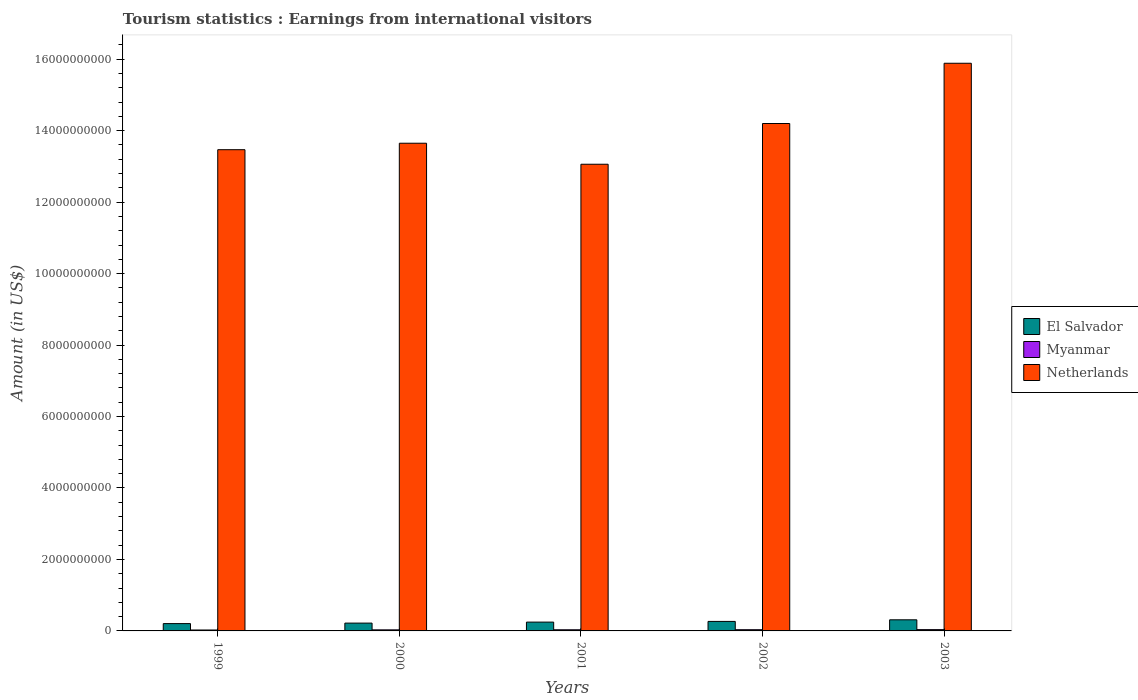How many different coloured bars are there?
Ensure brevity in your answer.  3. Are the number of bars on each tick of the X-axis equal?
Provide a short and direct response. Yes. In how many cases, is the number of bars for a given year not equal to the number of legend labels?
Offer a very short reply. 0. What is the earnings from international visitors in Myanmar in 2001?
Your answer should be very brief. 3.20e+07. Across all years, what is the maximum earnings from international visitors in El Salvador?
Make the answer very short. 3.11e+08. Across all years, what is the minimum earnings from international visitors in Myanmar?
Give a very brief answer. 2.60e+07. In which year was the earnings from international visitors in Myanmar maximum?
Your answer should be very brief. 2003. What is the total earnings from international visitors in Netherlands in the graph?
Keep it short and to the point. 7.03e+1. What is the difference between the earnings from international visitors in Netherlands in 1999 and that in 2002?
Ensure brevity in your answer.  -7.33e+08. What is the difference between the earnings from international visitors in Netherlands in 2000 and the earnings from international visitors in Myanmar in 1999?
Make the answer very short. 1.36e+1. What is the average earnings from international visitors in Myanmar per year?
Offer a very short reply. 3.16e+07. In the year 2000, what is the difference between the earnings from international visitors in Netherlands and earnings from international visitors in Myanmar?
Offer a terse response. 1.36e+1. In how many years, is the earnings from international visitors in Myanmar greater than 12400000000 US$?
Offer a terse response. 0. What is the ratio of the earnings from international visitors in Myanmar in 1999 to that in 2003?
Ensure brevity in your answer.  0.72. Is the difference between the earnings from international visitors in Netherlands in 2001 and 2002 greater than the difference between the earnings from international visitors in Myanmar in 2001 and 2002?
Give a very brief answer. No. What is the difference between the highest and the lowest earnings from international visitors in Myanmar?
Your answer should be compact. 1.00e+07. In how many years, is the earnings from international visitors in El Salvador greater than the average earnings from international visitors in El Salvador taken over all years?
Provide a succinct answer. 2. Is the sum of the earnings from international visitors in Netherlands in 1999 and 2000 greater than the maximum earnings from international visitors in Myanmar across all years?
Offer a terse response. Yes. What does the 1st bar from the left in 2002 represents?
Your answer should be very brief. El Salvador. What does the 2nd bar from the right in 2002 represents?
Your response must be concise. Myanmar. What is the difference between two consecutive major ticks on the Y-axis?
Provide a short and direct response. 2.00e+09. Does the graph contain any zero values?
Give a very brief answer. No. Where does the legend appear in the graph?
Keep it short and to the point. Center right. How many legend labels are there?
Your response must be concise. 3. What is the title of the graph?
Ensure brevity in your answer.  Tourism statistics : Earnings from international visitors. Does "Belgium" appear as one of the legend labels in the graph?
Provide a succinct answer. No. What is the label or title of the X-axis?
Provide a short and direct response. Years. What is the label or title of the Y-axis?
Provide a succinct answer. Amount (in US$). What is the Amount (in US$) in El Salvador in 1999?
Make the answer very short. 2.05e+08. What is the Amount (in US$) of Myanmar in 1999?
Your answer should be compact. 2.60e+07. What is the Amount (in US$) of Netherlands in 1999?
Give a very brief answer. 1.35e+1. What is the Amount (in US$) of El Salvador in 2000?
Your response must be concise. 2.19e+08. What is the Amount (in US$) in Myanmar in 2000?
Your response must be concise. 3.00e+07. What is the Amount (in US$) in Netherlands in 2000?
Your answer should be very brief. 1.36e+1. What is the Amount (in US$) of El Salvador in 2001?
Provide a succinct answer. 2.47e+08. What is the Amount (in US$) in Myanmar in 2001?
Provide a succinct answer. 3.20e+07. What is the Amount (in US$) of Netherlands in 2001?
Provide a succinct answer. 1.31e+1. What is the Amount (in US$) in El Salvador in 2002?
Provide a short and direct response. 2.66e+08. What is the Amount (in US$) in Myanmar in 2002?
Make the answer very short. 3.40e+07. What is the Amount (in US$) of Netherlands in 2002?
Provide a short and direct response. 1.42e+1. What is the Amount (in US$) of El Salvador in 2003?
Provide a succinct answer. 3.11e+08. What is the Amount (in US$) in Myanmar in 2003?
Make the answer very short. 3.60e+07. What is the Amount (in US$) in Netherlands in 2003?
Provide a short and direct response. 1.59e+1. Across all years, what is the maximum Amount (in US$) of El Salvador?
Offer a terse response. 3.11e+08. Across all years, what is the maximum Amount (in US$) in Myanmar?
Offer a terse response. 3.60e+07. Across all years, what is the maximum Amount (in US$) of Netherlands?
Your answer should be compact. 1.59e+1. Across all years, what is the minimum Amount (in US$) in El Salvador?
Make the answer very short. 2.05e+08. Across all years, what is the minimum Amount (in US$) in Myanmar?
Your response must be concise. 2.60e+07. Across all years, what is the minimum Amount (in US$) of Netherlands?
Make the answer very short. 1.31e+1. What is the total Amount (in US$) of El Salvador in the graph?
Your response must be concise. 1.25e+09. What is the total Amount (in US$) of Myanmar in the graph?
Make the answer very short. 1.58e+08. What is the total Amount (in US$) in Netherlands in the graph?
Offer a terse response. 7.03e+1. What is the difference between the Amount (in US$) in El Salvador in 1999 and that in 2000?
Ensure brevity in your answer.  -1.40e+07. What is the difference between the Amount (in US$) in Myanmar in 1999 and that in 2000?
Your response must be concise. -4.00e+06. What is the difference between the Amount (in US$) in Netherlands in 1999 and that in 2000?
Ensure brevity in your answer.  -1.81e+08. What is the difference between the Amount (in US$) in El Salvador in 1999 and that in 2001?
Offer a terse response. -4.20e+07. What is the difference between the Amount (in US$) of Myanmar in 1999 and that in 2001?
Keep it short and to the point. -6.00e+06. What is the difference between the Amount (in US$) of Netherlands in 1999 and that in 2001?
Your response must be concise. 4.07e+08. What is the difference between the Amount (in US$) in El Salvador in 1999 and that in 2002?
Offer a terse response. -6.10e+07. What is the difference between the Amount (in US$) in Myanmar in 1999 and that in 2002?
Make the answer very short. -8.00e+06. What is the difference between the Amount (in US$) in Netherlands in 1999 and that in 2002?
Provide a succinct answer. -7.33e+08. What is the difference between the Amount (in US$) in El Salvador in 1999 and that in 2003?
Your response must be concise. -1.06e+08. What is the difference between the Amount (in US$) of Myanmar in 1999 and that in 2003?
Make the answer very short. -1.00e+07. What is the difference between the Amount (in US$) in Netherlands in 1999 and that in 2003?
Keep it short and to the point. -2.42e+09. What is the difference between the Amount (in US$) in El Salvador in 2000 and that in 2001?
Provide a succinct answer. -2.80e+07. What is the difference between the Amount (in US$) in Myanmar in 2000 and that in 2001?
Your answer should be very brief. -2.00e+06. What is the difference between the Amount (in US$) of Netherlands in 2000 and that in 2001?
Make the answer very short. 5.88e+08. What is the difference between the Amount (in US$) of El Salvador in 2000 and that in 2002?
Your response must be concise. -4.70e+07. What is the difference between the Amount (in US$) in Myanmar in 2000 and that in 2002?
Offer a terse response. -4.00e+06. What is the difference between the Amount (in US$) of Netherlands in 2000 and that in 2002?
Offer a terse response. -5.52e+08. What is the difference between the Amount (in US$) in El Salvador in 2000 and that in 2003?
Your answer should be very brief. -9.20e+07. What is the difference between the Amount (in US$) in Myanmar in 2000 and that in 2003?
Make the answer very short. -6.00e+06. What is the difference between the Amount (in US$) of Netherlands in 2000 and that in 2003?
Offer a terse response. -2.24e+09. What is the difference between the Amount (in US$) of El Salvador in 2001 and that in 2002?
Provide a short and direct response. -1.90e+07. What is the difference between the Amount (in US$) of Myanmar in 2001 and that in 2002?
Give a very brief answer. -2.00e+06. What is the difference between the Amount (in US$) of Netherlands in 2001 and that in 2002?
Your answer should be compact. -1.14e+09. What is the difference between the Amount (in US$) of El Salvador in 2001 and that in 2003?
Offer a terse response. -6.40e+07. What is the difference between the Amount (in US$) in Myanmar in 2001 and that in 2003?
Make the answer very short. -4.00e+06. What is the difference between the Amount (in US$) in Netherlands in 2001 and that in 2003?
Ensure brevity in your answer.  -2.83e+09. What is the difference between the Amount (in US$) of El Salvador in 2002 and that in 2003?
Your answer should be very brief. -4.50e+07. What is the difference between the Amount (in US$) in Myanmar in 2002 and that in 2003?
Your response must be concise. -2.00e+06. What is the difference between the Amount (in US$) in Netherlands in 2002 and that in 2003?
Keep it short and to the point. -1.69e+09. What is the difference between the Amount (in US$) in El Salvador in 1999 and the Amount (in US$) in Myanmar in 2000?
Ensure brevity in your answer.  1.75e+08. What is the difference between the Amount (in US$) in El Salvador in 1999 and the Amount (in US$) in Netherlands in 2000?
Give a very brief answer. -1.34e+1. What is the difference between the Amount (in US$) of Myanmar in 1999 and the Amount (in US$) of Netherlands in 2000?
Keep it short and to the point. -1.36e+1. What is the difference between the Amount (in US$) in El Salvador in 1999 and the Amount (in US$) in Myanmar in 2001?
Keep it short and to the point. 1.73e+08. What is the difference between the Amount (in US$) in El Salvador in 1999 and the Amount (in US$) in Netherlands in 2001?
Provide a short and direct response. -1.29e+1. What is the difference between the Amount (in US$) of Myanmar in 1999 and the Amount (in US$) of Netherlands in 2001?
Your answer should be compact. -1.30e+1. What is the difference between the Amount (in US$) in El Salvador in 1999 and the Amount (in US$) in Myanmar in 2002?
Your response must be concise. 1.71e+08. What is the difference between the Amount (in US$) in El Salvador in 1999 and the Amount (in US$) in Netherlands in 2002?
Offer a terse response. -1.40e+1. What is the difference between the Amount (in US$) in Myanmar in 1999 and the Amount (in US$) in Netherlands in 2002?
Make the answer very short. -1.42e+1. What is the difference between the Amount (in US$) of El Salvador in 1999 and the Amount (in US$) of Myanmar in 2003?
Your answer should be very brief. 1.69e+08. What is the difference between the Amount (in US$) of El Salvador in 1999 and the Amount (in US$) of Netherlands in 2003?
Offer a terse response. -1.57e+1. What is the difference between the Amount (in US$) of Myanmar in 1999 and the Amount (in US$) of Netherlands in 2003?
Offer a very short reply. -1.59e+1. What is the difference between the Amount (in US$) of El Salvador in 2000 and the Amount (in US$) of Myanmar in 2001?
Provide a short and direct response. 1.87e+08. What is the difference between the Amount (in US$) in El Salvador in 2000 and the Amount (in US$) in Netherlands in 2001?
Your response must be concise. -1.28e+1. What is the difference between the Amount (in US$) of Myanmar in 2000 and the Amount (in US$) of Netherlands in 2001?
Provide a succinct answer. -1.30e+1. What is the difference between the Amount (in US$) of El Salvador in 2000 and the Amount (in US$) of Myanmar in 2002?
Make the answer very short. 1.85e+08. What is the difference between the Amount (in US$) in El Salvador in 2000 and the Amount (in US$) in Netherlands in 2002?
Provide a succinct answer. -1.40e+1. What is the difference between the Amount (in US$) in Myanmar in 2000 and the Amount (in US$) in Netherlands in 2002?
Make the answer very short. -1.42e+1. What is the difference between the Amount (in US$) of El Salvador in 2000 and the Amount (in US$) of Myanmar in 2003?
Provide a short and direct response. 1.83e+08. What is the difference between the Amount (in US$) in El Salvador in 2000 and the Amount (in US$) in Netherlands in 2003?
Provide a succinct answer. -1.57e+1. What is the difference between the Amount (in US$) in Myanmar in 2000 and the Amount (in US$) in Netherlands in 2003?
Your answer should be very brief. -1.59e+1. What is the difference between the Amount (in US$) of El Salvador in 2001 and the Amount (in US$) of Myanmar in 2002?
Your response must be concise. 2.13e+08. What is the difference between the Amount (in US$) of El Salvador in 2001 and the Amount (in US$) of Netherlands in 2002?
Provide a succinct answer. -1.40e+1. What is the difference between the Amount (in US$) of Myanmar in 2001 and the Amount (in US$) of Netherlands in 2002?
Ensure brevity in your answer.  -1.42e+1. What is the difference between the Amount (in US$) of El Salvador in 2001 and the Amount (in US$) of Myanmar in 2003?
Offer a terse response. 2.11e+08. What is the difference between the Amount (in US$) of El Salvador in 2001 and the Amount (in US$) of Netherlands in 2003?
Offer a terse response. -1.56e+1. What is the difference between the Amount (in US$) of Myanmar in 2001 and the Amount (in US$) of Netherlands in 2003?
Keep it short and to the point. -1.59e+1. What is the difference between the Amount (in US$) of El Salvador in 2002 and the Amount (in US$) of Myanmar in 2003?
Ensure brevity in your answer.  2.30e+08. What is the difference between the Amount (in US$) of El Salvador in 2002 and the Amount (in US$) of Netherlands in 2003?
Provide a succinct answer. -1.56e+1. What is the difference between the Amount (in US$) of Myanmar in 2002 and the Amount (in US$) of Netherlands in 2003?
Provide a succinct answer. -1.59e+1. What is the average Amount (in US$) in El Salvador per year?
Provide a short and direct response. 2.50e+08. What is the average Amount (in US$) in Myanmar per year?
Give a very brief answer. 3.16e+07. What is the average Amount (in US$) of Netherlands per year?
Provide a succinct answer. 1.41e+1. In the year 1999, what is the difference between the Amount (in US$) in El Salvador and Amount (in US$) in Myanmar?
Make the answer very short. 1.79e+08. In the year 1999, what is the difference between the Amount (in US$) of El Salvador and Amount (in US$) of Netherlands?
Your answer should be compact. -1.33e+1. In the year 1999, what is the difference between the Amount (in US$) in Myanmar and Amount (in US$) in Netherlands?
Offer a very short reply. -1.34e+1. In the year 2000, what is the difference between the Amount (in US$) of El Salvador and Amount (in US$) of Myanmar?
Keep it short and to the point. 1.89e+08. In the year 2000, what is the difference between the Amount (in US$) in El Salvador and Amount (in US$) in Netherlands?
Provide a succinct answer. -1.34e+1. In the year 2000, what is the difference between the Amount (in US$) of Myanmar and Amount (in US$) of Netherlands?
Provide a short and direct response. -1.36e+1. In the year 2001, what is the difference between the Amount (in US$) of El Salvador and Amount (in US$) of Myanmar?
Offer a very short reply. 2.15e+08. In the year 2001, what is the difference between the Amount (in US$) of El Salvador and Amount (in US$) of Netherlands?
Your answer should be compact. -1.28e+1. In the year 2001, what is the difference between the Amount (in US$) of Myanmar and Amount (in US$) of Netherlands?
Your answer should be very brief. -1.30e+1. In the year 2002, what is the difference between the Amount (in US$) in El Salvador and Amount (in US$) in Myanmar?
Make the answer very short. 2.32e+08. In the year 2002, what is the difference between the Amount (in US$) of El Salvador and Amount (in US$) of Netherlands?
Provide a succinct answer. -1.39e+1. In the year 2002, what is the difference between the Amount (in US$) in Myanmar and Amount (in US$) in Netherlands?
Ensure brevity in your answer.  -1.42e+1. In the year 2003, what is the difference between the Amount (in US$) in El Salvador and Amount (in US$) in Myanmar?
Your answer should be compact. 2.75e+08. In the year 2003, what is the difference between the Amount (in US$) of El Salvador and Amount (in US$) of Netherlands?
Ensure brevity in your answer.  -1.56e+1. In the year 2003, what is the difference between the Amount (in US$) of Myanmar and Amount (in US$) of Netherlands?
Keep it short and to the point. -1.59e+1. What is the ratio of the Amount (in US$) of El Salvador in 1999 to that in 2000?
Offer a very short reply. 0.94. What is the ratio of the Amount (in US$) of Myanmar in 1999 to that in 2000?
Give a very brief answer. 0.87. What is the ratio of the Amount (in US$) of Netherlands in 1999 to that in 2000?
Make the answer very short. 0.99. What is the ratio of the Amount (in US$) in El Salvador in 1999 to that in 2001?
Give a very brief answer. 0.83. What is the ratio of the Amount (in US$) in Myanmar in 1999 to that in 2001?
Keep it short and to the point. 0.81. What is the ratio of the Amount (in US$) of Netherlands in 1999 to that in 2001?
Your response must be concise. 1.03. What is the ratio of the Amount (in US$) in El Salvador in 1999 to that in 2002?
Offer a terse response. 0.77. What is the ratio of the Amount (in US$) of Myanmar in 1999 to that in 2002?
Make the answer very short. 0.76. What is the ratio of the Amount (in US$) of Netherlands in 1999 to that in 2002?
Provide a short and direct response. 0.95. What is the ratio of the Amount (in US$) of El Salvador in 1999 to that in 2003?
Give a very brief answer. 0.66. What is the ratio of the Amount (in US$) of Myanmar in 1999 to that in 2003?
Provide a short and direct response. 0.72. What is the ratio of the Amount (in US$) in Netherlands in 1999 to that in 2003?
Ensure brevity in your answer.  0.85. What is the ratio of the Amount (in US$) in El Salvador in 2000 to that in 2001?
Make the answer very short. 0.89. What is the ratio of the Amount (in US$) in Myanmar in 2000 to that in 2001?
Provide a succinct answer. 0.94. What is the ratio of the Amount (in US$) of Netherlands in 2000 to that in 2001?
Provide a succinct answer. 1.04. What is the ratio of the Amount (in US$) of El Salvador in 2000 to that in 2002?
Your answer should be compact. 0.82. What is the ratio of the Amount (in US$) in Myanmar in 2000 to that in 2002?
Provide a short and direct response. 0.88. What is the ratio of the Amount (in US$) in Netherlands in 2000 to that in 2002?
Provide a short and direct response. 0.96. What is the ratio of the Amount (in US$) of El Salvador in 2000 to that in 2003?
Your answer should be compact. 0.7. What is the ratio of the Amount (in US$) in Myanmar in 2000 to that in 2003?
Offer a terse response. 0.83. What is the ratio of the Amount (in US$) of Netherlands in 2000 to that in 2003?
Your answer should be very brief. 0.86. What is the ratio of the Amount (in US$) of El Salvador in 2001 to that in 2002?
Give a very brief answer. 0.93. What is the ratio of the Amount (in US$) in Netherlands in 2001 to that in 2002?
Provide a short and direct response. 0.92. What is the ratio of the Amount (in US$) of El Salvador in 2001 to that in 2003?
Your answer should be very brief. 0.79. What is the ratio of the Amount (in US$) in Myanmar in 2001 to that in 2003?
Your response must be concise. 0.89. What is the ratio of the Amount (in US$) in Netherlands in 2001 to that in 2003?
Your answer should be very brief. 0.82. What is the ratio of the Amount (in US$) of El Salvador in 2002 to that in 2003?
Offer a terse response. 0.86. What is the ratio of the Amount (in US$) in Myanmar in 2002 to that in 2003?
Your response must be concise. 0.94. What is the ratio of the Amount (in US$) of Netherlands in 2002 to that in 2003?
Give a very brief answer. 0.89. What is the difference between the highest and the second highest Amount (in US$) of El Salvador?
Your answer should be compact. 4.50e+07. What is the difference between the highest and the second highest Amount (in US$) of Netherlands?
Give a very brief answer. 1.69e+09. What is the difference between the highest and the lowest Amount (in US$) in El Salvador?
Keep it short and to the point. 1.06e+08. What is the difference between the highest and the lowest Amount (in US$) in Myanmar?
Make the answer very short. 1.00e+07. What is the difference between the highest and the lowest Amount (in US$) in Netherlands?
Give a very brief answer. 2.83e+09. 